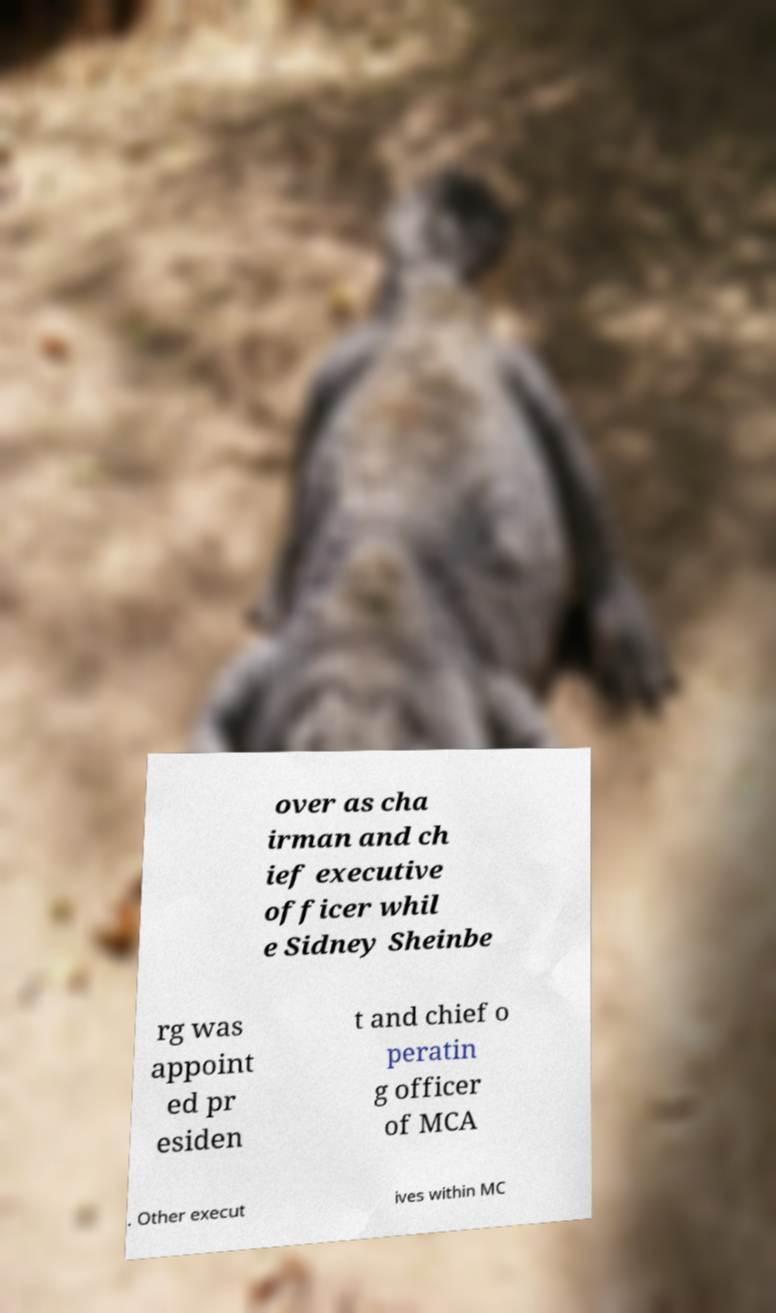Can you accurately transcribe the text from the provided image for me? over as cha irman and ch ief executive officer whil e Sidney Sheinbe rg was appoint ed pr esiden t and chief o peratin g officer of MCA . Other execut ives within MC 